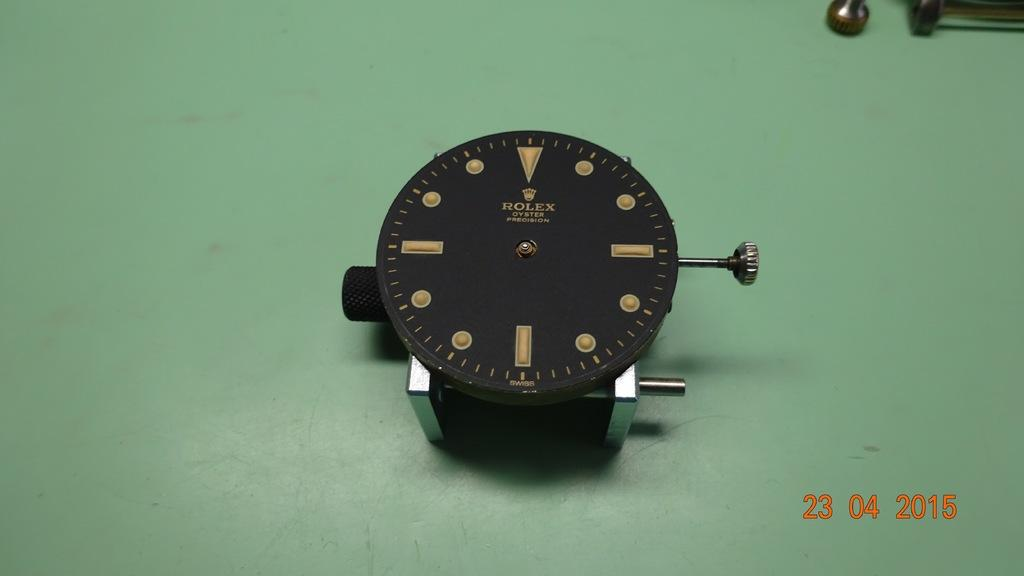<image>
Relay a brief, clear account of the picture shown. A Rolex oyster watch face is sitting on a table. 